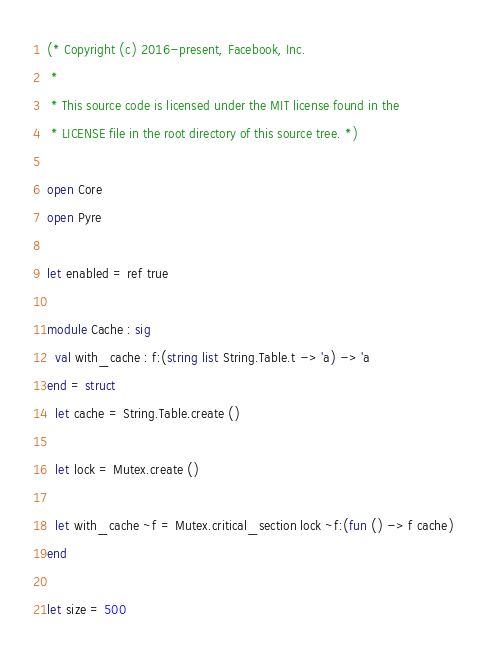<code> <loc_0><loc_0><loc_500><loc_500><_OCaml_>(* Copyright (c) 2016-present, Facebook, Inc.
 *
 * This source code is licensed under the MIT license found in the
 * LICENSE file in the root directory of this source tree. *)

open Core
open Pyre

let enabled = ref true

module Cache : sig
  val with_cache : f:(string list String.Table.t -> 'a) -> 'a
end = struct
  let cache = String.Table.create ()

  let lock = Mutex.create ()

  let with_cache ~f = Mutex.critical_section lock ~f:(fun () -> f cache)
end

let size = 500
</code> 